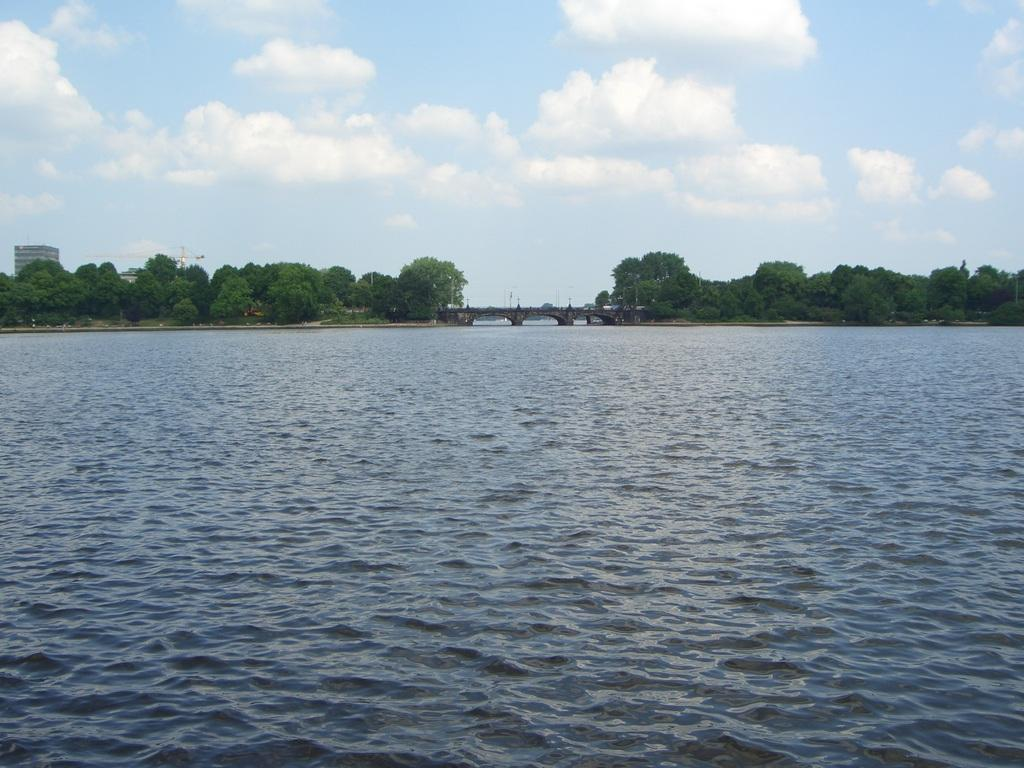What is the setting of the image? The image has an outside view. What can be seen in the foreground of the image? There is a lake in the foreground of the image. What is located in the middle of the image? There is a bridge and trees in the middle of the image. What is visible in the background of the image? There is a sky visible in the background of the image. How many babies are crawling on the bridge in the image? There are no babies present in the image; it features a lake, a bridge, and trees. 